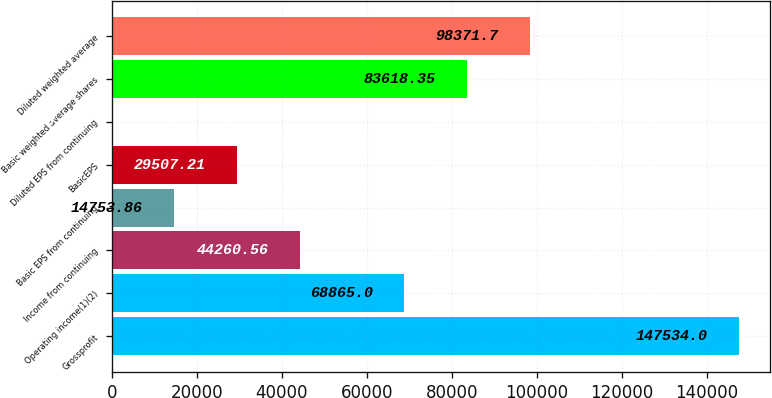<chart> <loc_0><loc_0><loc_500><loc_500><bar_chart><fcel>Grossprofit<fcel>Operating income(1)(2)<fcel>Income from continuing<fcel>Basic EPS from continuing<fcel>BasicEPS<fcel>Diluted EPS from continuing<fcel>Basic weighted average shares<fcel>Diluted weighted average<nl><fcel>147534<fcel>68865<fcel>44260.6<fcel>14753.9<fcel>29507.2<fcel>0.51<fcel>83618.4<fcel>98371.7<nl></chart> 